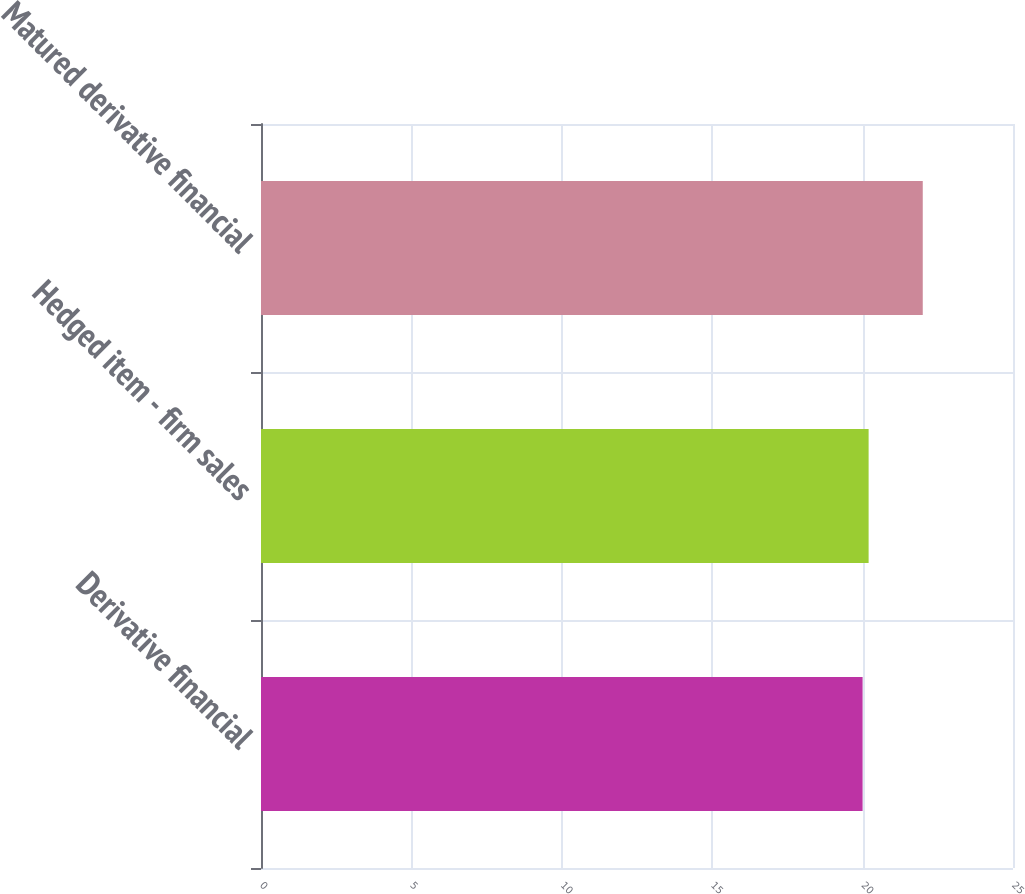Convert chart to OTSL. <chart><loc_0><loc_0><loc_500><loc_500><bar_chart><fcel>Derivative financial<fcel>Hedged item - firm sales<fcel>Matured derivative financial<nl><fcel>20<fcel>20.2<fcel>22<nl></chart> 